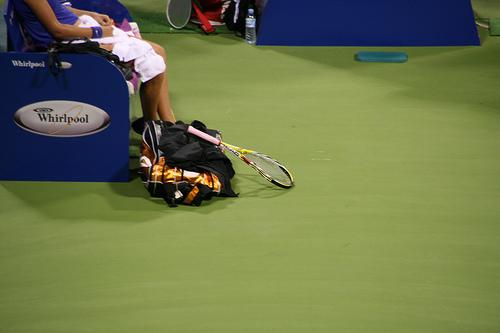What brand appears on the wristband and which body part is it intended for? The Nike brand appears on the wristband, which is meant for the arm. Describe the position and activity of the person in the image. The person is sitting on a blue bench with their legs crossed and is relaxing after playing a game. Analyze the image sentiment based on the provided information. The image sentiment is positive and leisurely, as it shows a person enjoying their day and having recreation at a tennis court. List three objects besides the tennis racket that are related to tennis and how they are placed. A yellow and black bag is under the tennis racket, a water bottle with a blue lid is on the floor, and a blue Nike wristband with a white symbol is beside them. Identify the color and type of the tennis racket handle. The tennis racket handle is pink. What is the total number of letters mentioned in the image? 9 letters. What type of flooring is in the image and what color is it? The flooring is green low nap carpeting. What advertisement is shown on the bench and what is its color? A Whirlpool advertisement is shown on the bench, and its color is blue. In 4-6 words, describe the overall setting of the image. Tennis court with players and equipment. Based on the color and flooring of the courts, summarize the image's aesthetic appeal in one sentence. The image has a vibrant, engaging aesthetic with green carpeting and colorful equipment. 